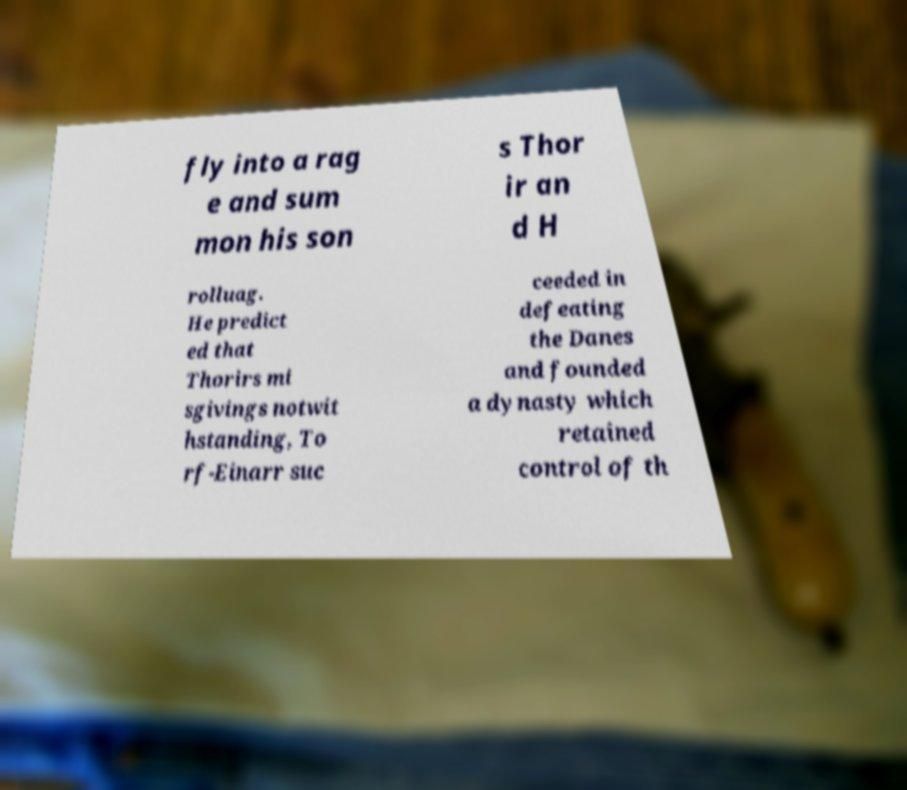Please read and relay the text visible in this image. What does it say? fly into a rag e and sum mon his son s Thor ir an d H rolluag. He predict ed that Thorirs mi sgivings notwit hstanding, To rf-Einarr suc ceeded in defeating the Danes and founded a dynasty which retained control of th 